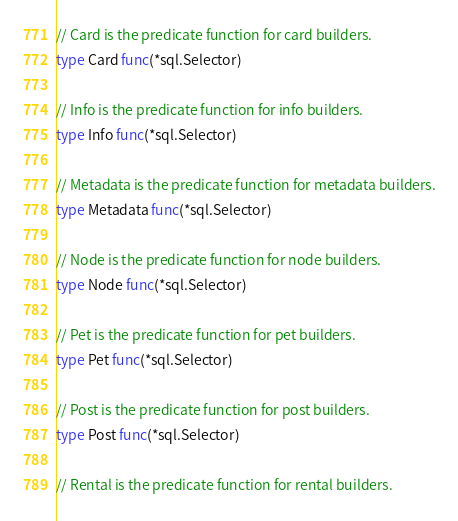<code> <loc_0><loc_0><loc_500><loc_500><_Go_>
// Card is the predicate function for card builders.
type Card func(*sql.Selector)

// Info is the predicate function for info builders.
type Info func(*sql.Selector)

// Metadata is the predicate function for metadata builders.
type Metadata func(*sql.Selector)

// Node is the predicate function for node builders.
type Node func(*sql.Selector)

// Pet is the predicate function for pet builders.
type Pet func(*sql.Selector)

// Post is the predicate function for post builders.
type Post func(*sql.Selector)

// Rental is the predicate function for rental builders.</code> 